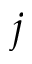<formula> <loc_0><loc_0><loc_500><loc_500>j</formula> 